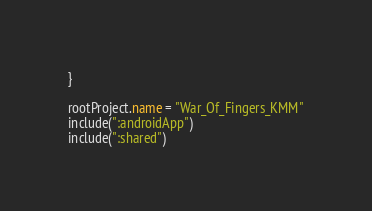<code> <loc_0><loc_0><loc_500><loc_500><_Kotlin_>}

rootProject.name = "War_Of_Fingers_KMM"
include(":androidApp")
include(":shared")</code> 